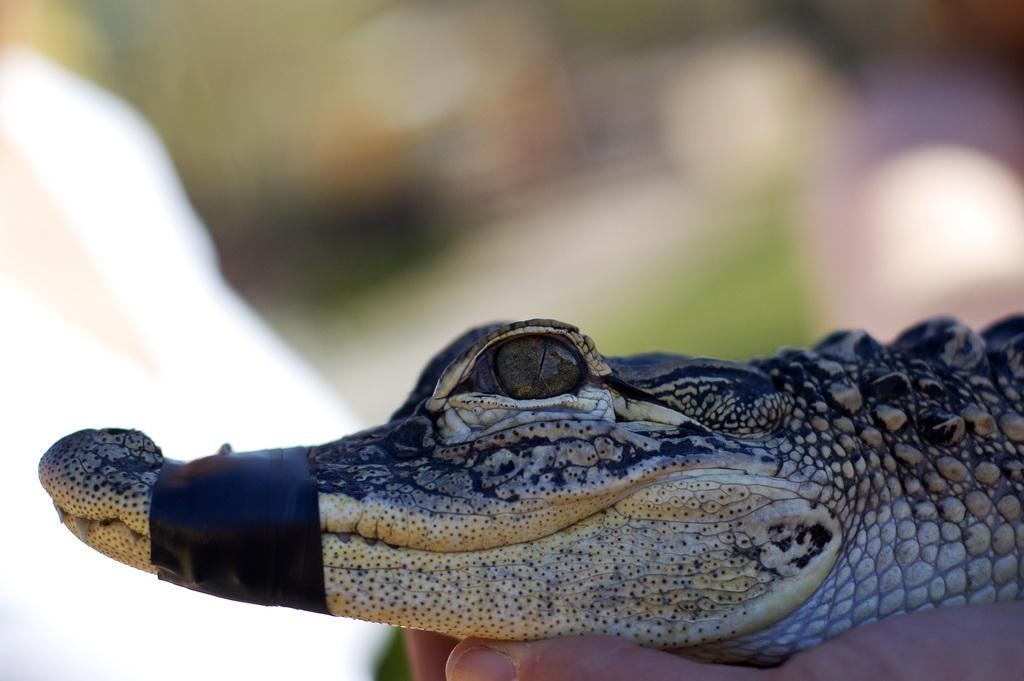What type of animal is in the image? There is a small crocodile in the image. How is the crocodile being handled in the image? The crocodile is being held by a human. What is covering the crocodile's mouth in the image? There is a black color plaster around the crocodile's mouth. Can you describe the background of the image? The background of the image is blurred. What type of star can be seen in the image? There is no star present in the image; it features a small crocodile being held by a human with a black color plaster around its mouth. 